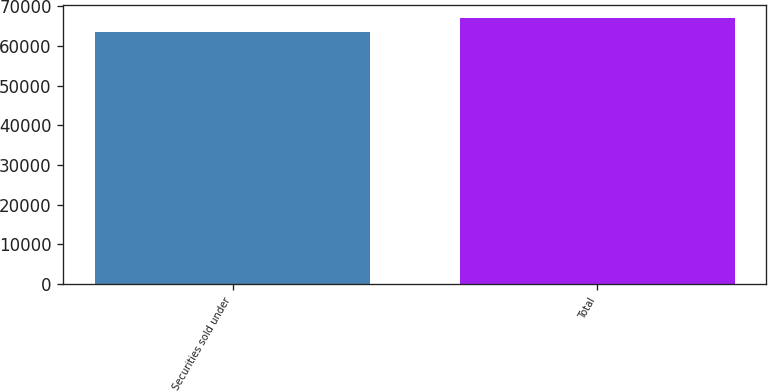Convert chart. <chart><loc_0><loc_0><loc_500><loc_500><bar_chart><fcel>Securities sold under<fcel>Total<nl><fcel>63517<fcel>67046<nl></chart> 